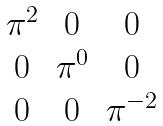<formula> <loc_0><loc_0><loc_500><loc_500>\begin{matrix} \pi ^ { 2 } & 0 & 0 \\ 0 & \pi ^ { 0 } & 0 \\ 0 & 0 & \pi ^ { - 2 } \end{matrix}</formula> 